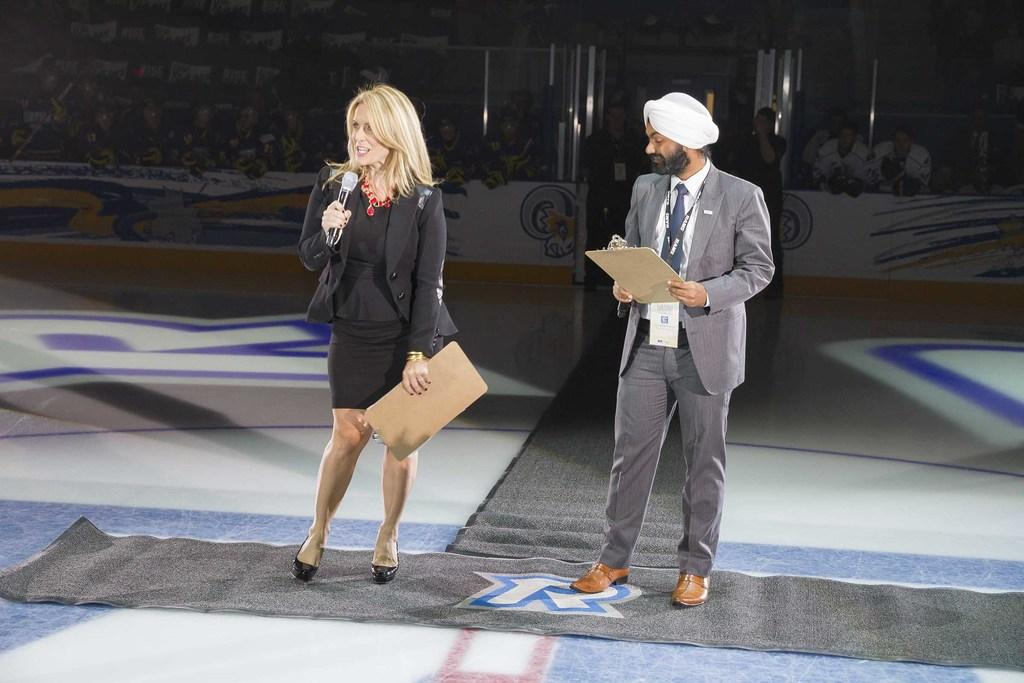What is the person wearing in the image? The person is wearing an ID card. What is the person holding in the image? The person is holding an object, but the specific object is not mentioned in the facts. What is the woman holding in the image? The woman is holding a microphone and a pad. Can you describe the background of the image? There are people in the background. What type of music is the sister playing in the image? There is no mention of a sister or music in the image, so it cannot be determined from the facts. 